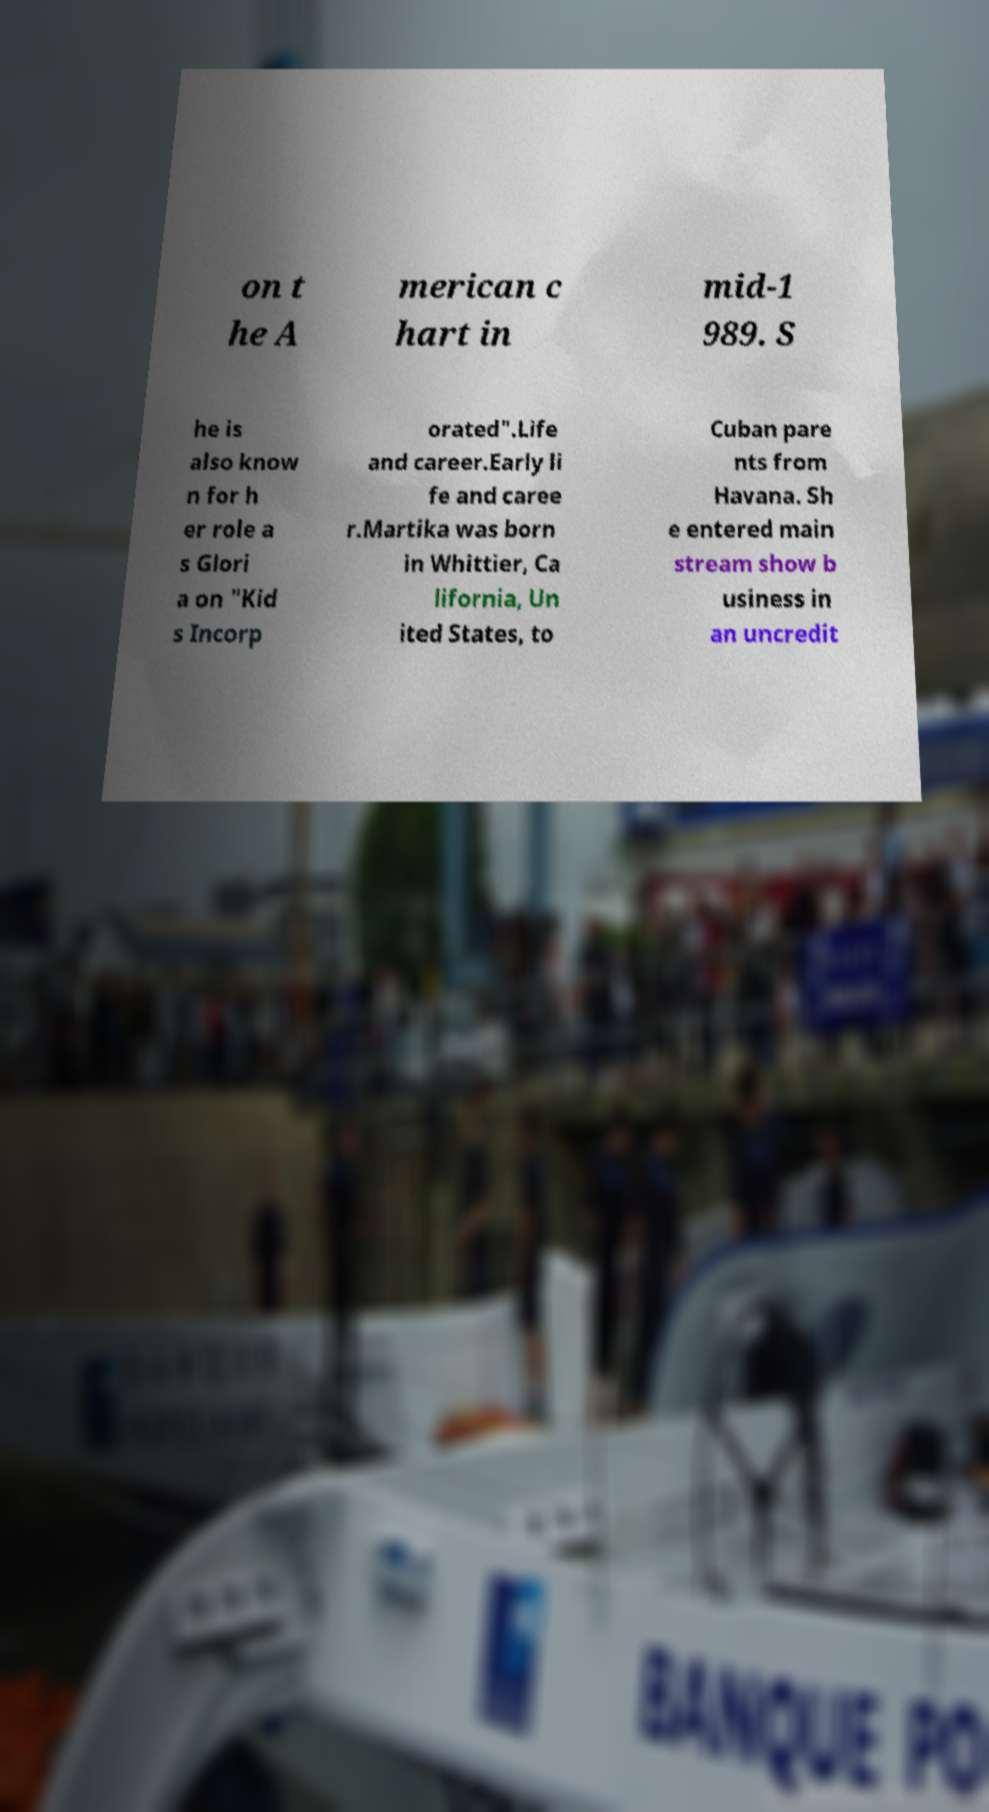What messages or text are displayed in this image? I need them in a readable, typed format. on t he A merican c hart in mid-1 989. S he is also know n for h er role a s Glori a on "Kid s Incorp orated".Life and career.Early li fe and caree r.Martika was born in Whittier, Ca lifornia, Un ited States, to Cuban pare nts from Havana. Sh e entered main stream show b usiness in an uncredit 